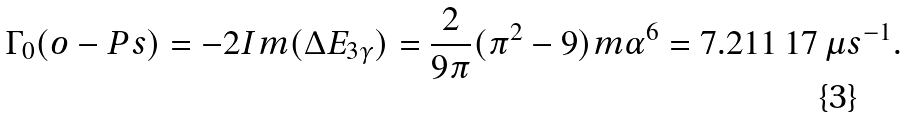<formula> <loc_0><loc_0><loc_500><loc_500>\Gamma _ { 0 } ( o - P s ) = - 2 I m ( \Delta E _ { 3 \gamma } ) = \frac { 2 } { 9 \pi } ( \pi ^ { 2 } - 9 ) m \alpha ^ { 6 } = 7 . 2 1 1 \, 1 7 \, \mu s ^ { - 1 } .</formula> 